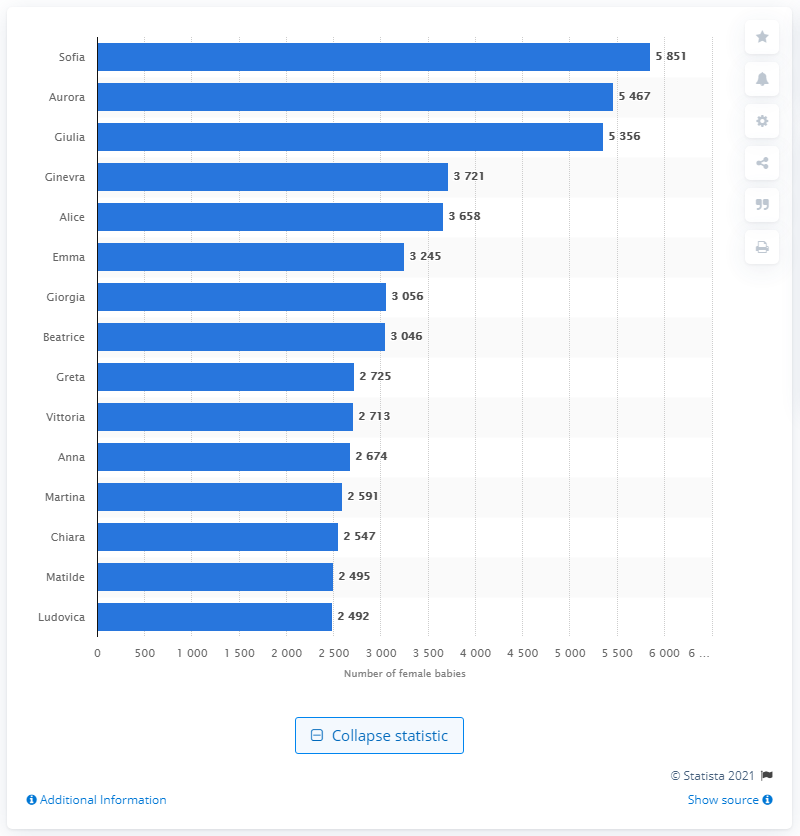List a handful of essential elements in this visual. In 2019, 5,851 Italian female babies were named Sofia. The most common female name in Italy is Sofia. 